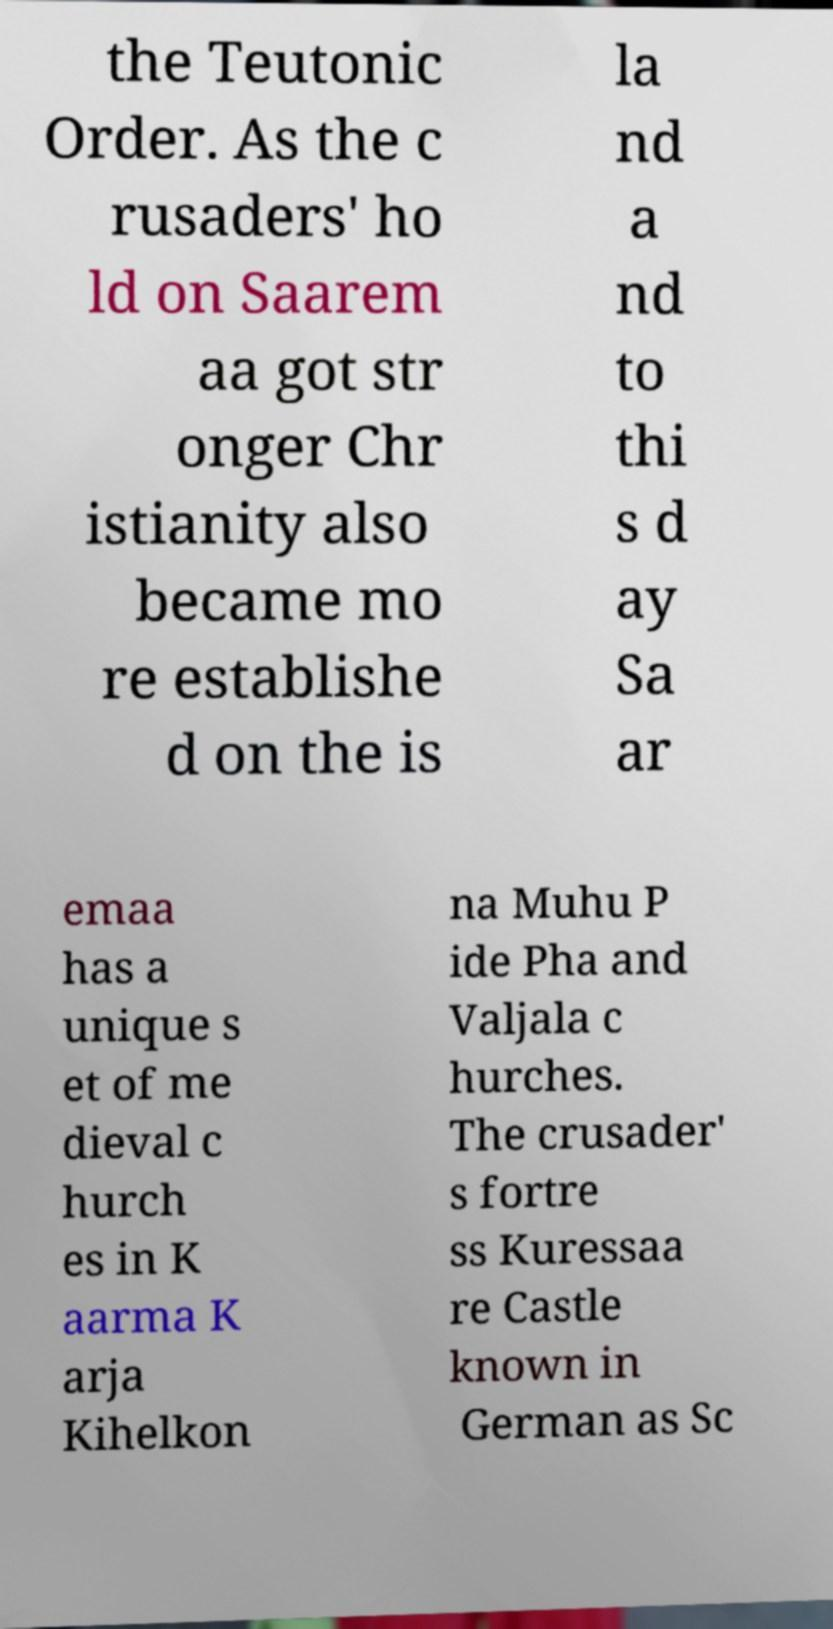Please identify and transcribe the text found in this image. the Teutonic Order. As the c rusaders' ho ld on Saarem aa got str onger Chr istianity also became mo re establishe d on the is la nd a nd to thi s d ay Sa ar emaa has a unique s et of me dieval c hurch es in K aarma K arja Kihelkon na Muhu P ide Pha and Valjala c hurches. The crusader' s fortre ss Kuressaa re Castle known in German as Sc 